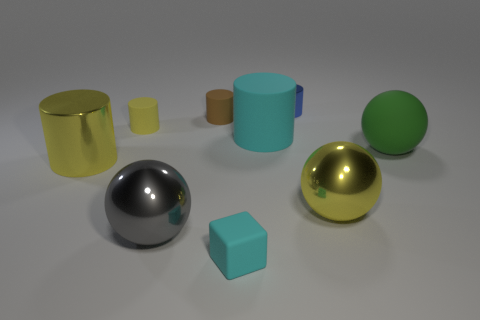Is the number of yellow metal spheres on the left side of the brown cylinder the same as the number of small matte cylinders?
Your answer should be very brief. No. Is the size of the blue object the same as the brown rubber cylinder?
Offer a terse response. Yes. There is a matte object that is both left of the big cyan rubber cylinder and right of the brown cylinder; what color is it?
Give a very brief answer. Cyan. There is a cyan thing that is behind the big yellow metal object to the right of the small shiny thing; what is it made of?
Your response must be concise. Rubber. The gray shiny thing that is the same shape as the green thing is what size?
Ensure brevity in your answer.  Large. There is a rubber object left of the gray metal thing; does it have the same color as the large metallic cylinder?
Ensure brevity in your answer.  Yes. Are there fewer cyan blocks than small green balls?
Make the answer very short. No. How many other things are there of the same color as the tiny metallic object?
Offer a terse response. 0. Does the big yellow object right of the blue shiny cylinder have the same material as the large cyan cylinder?
Offer a very short reply. No. What material is the small cylinder that is to the right of the tiny cyan rubber object?
Keep it short and to the point. Metal. 